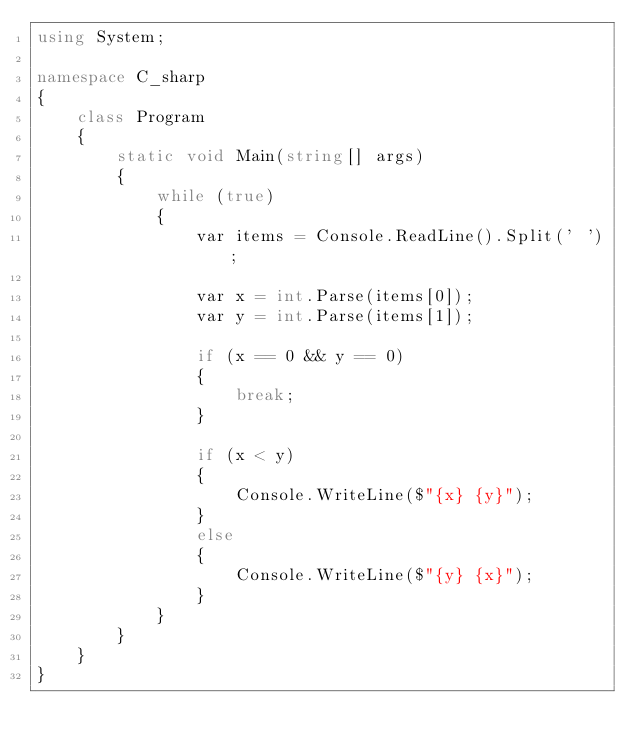Convert code to text. <code><loc_0><loc_0><loc_500><loc_500><_C#_>using System;

namespace C_sharp
{
    class Program
    {
        static void Main(string[] args)
        {
            while (true)
            {
                var items = Console.ReadLine().Split(' ');

                var x = int.Parse(items[0]);
                var y = int.Parse(items[1]);

                if (x == 0 && y == 0)
                {
                    break;
                }

                if (x < y)
                {
                    Console.WriteLine($"{x} {y}");
                }
                else
                {
                    Console.WriteLine($"{y} {x}");
                }
            }
        }
    }
}

</code> 